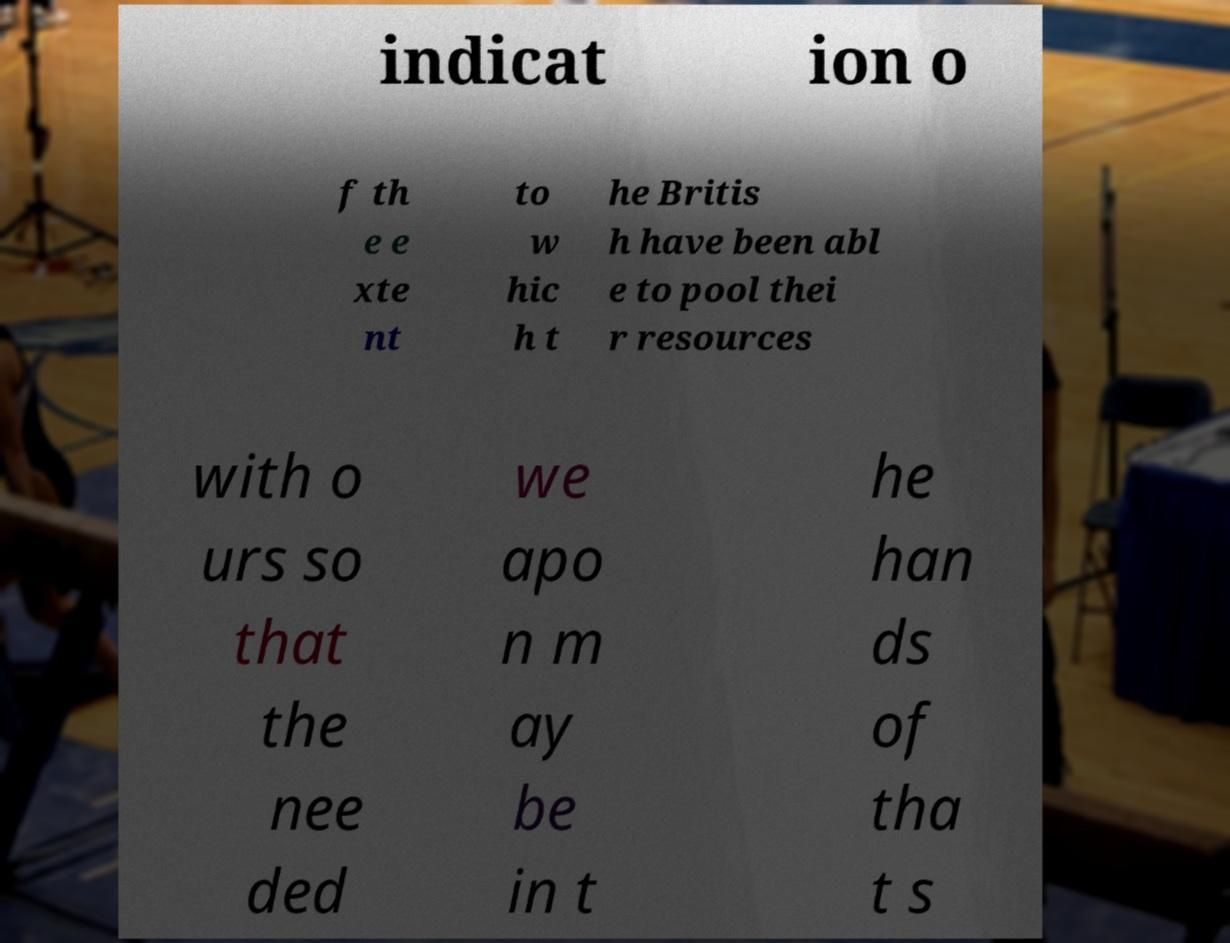Please read and relay the text visible in this image. What does it say? indicat ion o f th e e xte nt to w hic h t he Britis h have been abl e to pool thei r resources with o urs so that the nee ded we apo n m ay be in t he han ds of tha t s 